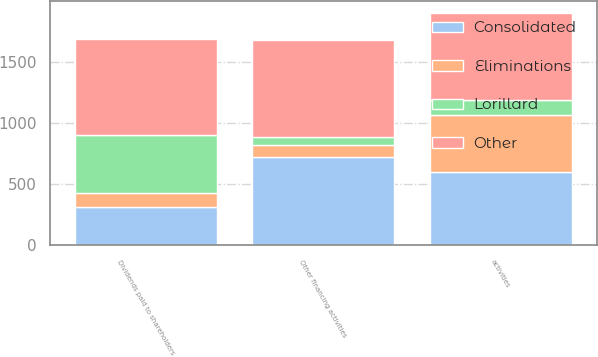<chart> <loc_0><loc_0><loc_500><loc_500><stacked_bar_chart><ecel><fcel>activities<fcel>Dividends paid to shareholders<fcel>Other financing activities<nl><fcel>Other<fcel>711.6<fcel>786<fcel>786<nl><fcel>Lorillard<fcel>116.1<fcel>472.1<fcel>66.1<nl><fcel>Consolidated<fcel>595.5<fcel>313.9<fcel>719.9<nl><fcel>Eliminations<fcel>472.1<fcel>111.3<fcel>101.4<nl></chart> 